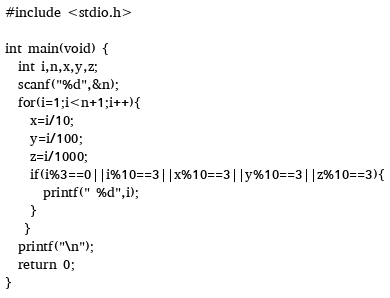Convert code to text. <code><loc_0><loc_0><loc_500><loc_500><_C_>#include <stdio.h>

int main(void) {
  int i,n,x,y,z;
  scanf("%d",&n);
  for(i=1;i<n+1;i++){
    x=i/10;
    y=i/100;
    z=i/1000;
    if(i%3==0||i%10==3||x%10==3||y%10==3||z%10==3){
      printf(" %d",i);
    }
   }
  printf("\n");
  return 0;
}
</code> 